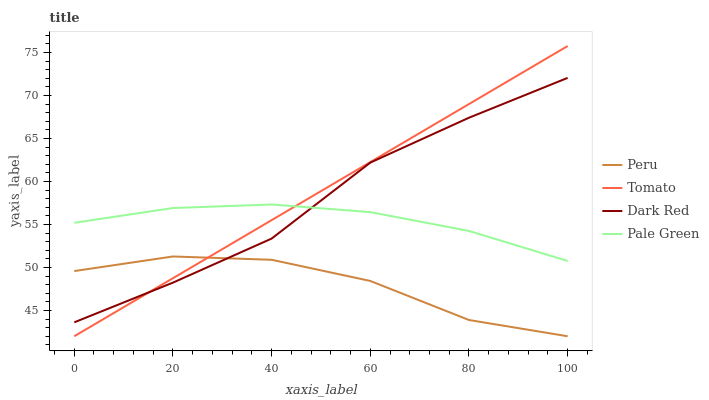Does Peru have the minimum area under the curve?
Answer yes or no. Yes. Does Tomato have the maximum area under the curve?
Answer yes or no. Yes. Does Dark Red have the minimum area under the curve?
Answer yes or no. No. Does Dark Red have the maximum area under the curve?
Answer yes or no. No. Is Tomato the smoothest?
Answer yes or no. Yes. Is Peru the roughest?
Answer yes or no. Yes. Is Dark Red the smoothest?
Answer yes or no. No. Is Dark Red the roughest?
Answer yes or no. No. Does Tomato have the lowest value?
Answer yes or no. Yes. Does Dark Red have the lowest value?
Answer yes or no. No. Does Tomato have the highest value?
Answer yes or no. Yes. Does Dark Red have the highest value?
Answer yes or no. No. Is Peru less than Pale Green?
Answer yes or no. Yes. Is Pale Green greater than Peru?
Answer yes or no. Yes. Does Dark Red intersect Peru?
Answer yes or no. Yes. Is Dark Red less than Peru?
Answer yes or no. No. Is Dark Red greater than Peru?
Answer yes or no. No. Does Peru intersect Pale Green?
Answer yes or no. No. 